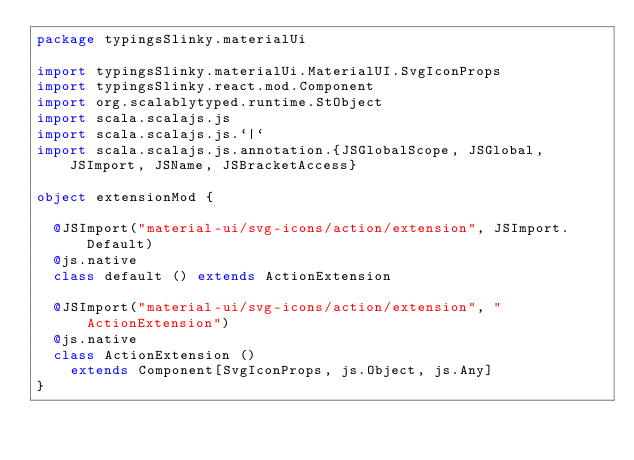Convert code to text. <code><loc_0><loc_0><loc_500><loc_500><_Scala_>package typingsSlinky.materialUi

import typingsSlinky.materialUi.MaterialUI.SvgIconProps
import typingsSlinky.react.mod.Component
import org.scalablytyped.runtime.StObject
import scala.scalajs.js
import scala.scalajs.js.`|`
import scala.scalajs.js.annotation.{JSGlobalScope, JSGlobal, JSImport, JSName, JSBracketAccess}

object extensionMod {
  
  @JSImport("material-ui/svg-icons/action/extension", JSImport.Default)
  @js.native
  class default () extends ActionExtension
  
  @JSImport("material-ui/svg-icons/action/extension", "ActionExtension")
  @js.native
  class ActionExtension ()
    extends Component[SvgIconProps, js.Object, js.Any]
}
</code> 